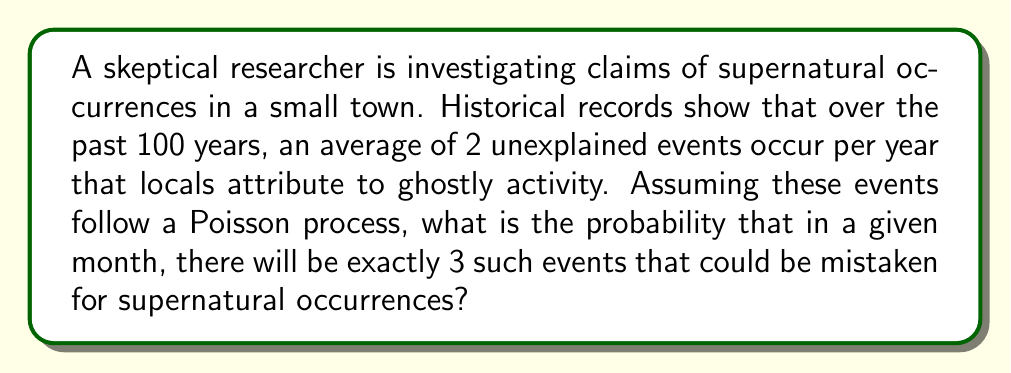Can you answer this question? Let's approach this step-by-step:

1) First, we need to identify the parameters of our Poisson process:
   - The rate λ (lambda) is given as 2 events per year.
   - We're asked about the probability in a given month, so we need to adjust λ for this time frame.

2) To get the monthly rate, we divide the yearly rate by 12:
   $$λ_{monthly} = \frac{2}{12} = \frac{1}{6} \approx 0.1667$$

3) Now we can use the Poisson probability mass function:
   $$P(X = k) = \frac{e^{-λ} λ^k}{k!}$$
   Where:
   - e is Euler's number (approximately 2.71828)
   - λ is our rate (0.1667 per month)
   - k is the number of events we're interested in (3 in this case)

4) Let's substitute these values:
   $$P(X = 3) = \frac{e^{-0.1667} (0.1667)^3}{3!}$$

5) Now let's calculate:
   $$P(X = 3) = \frac{2.71828^{-0.1667} \times 0.1667^3}{3 \times 2 \times 1}$$
   $$= \frac{0.8465 \times 0.004629}{6}$$
   $$= 0.0006532$$

6) This can be expressed as a percentage:
   $$0.0006532 \times 100\% = 0.06532\%$$

This very low probability suggests that observing 3 such events in a month would be quite rare, supporting the skeptical viewpoint that these are likely coincidences rather than supernatural occurrences.
Answer: 0.06532% 